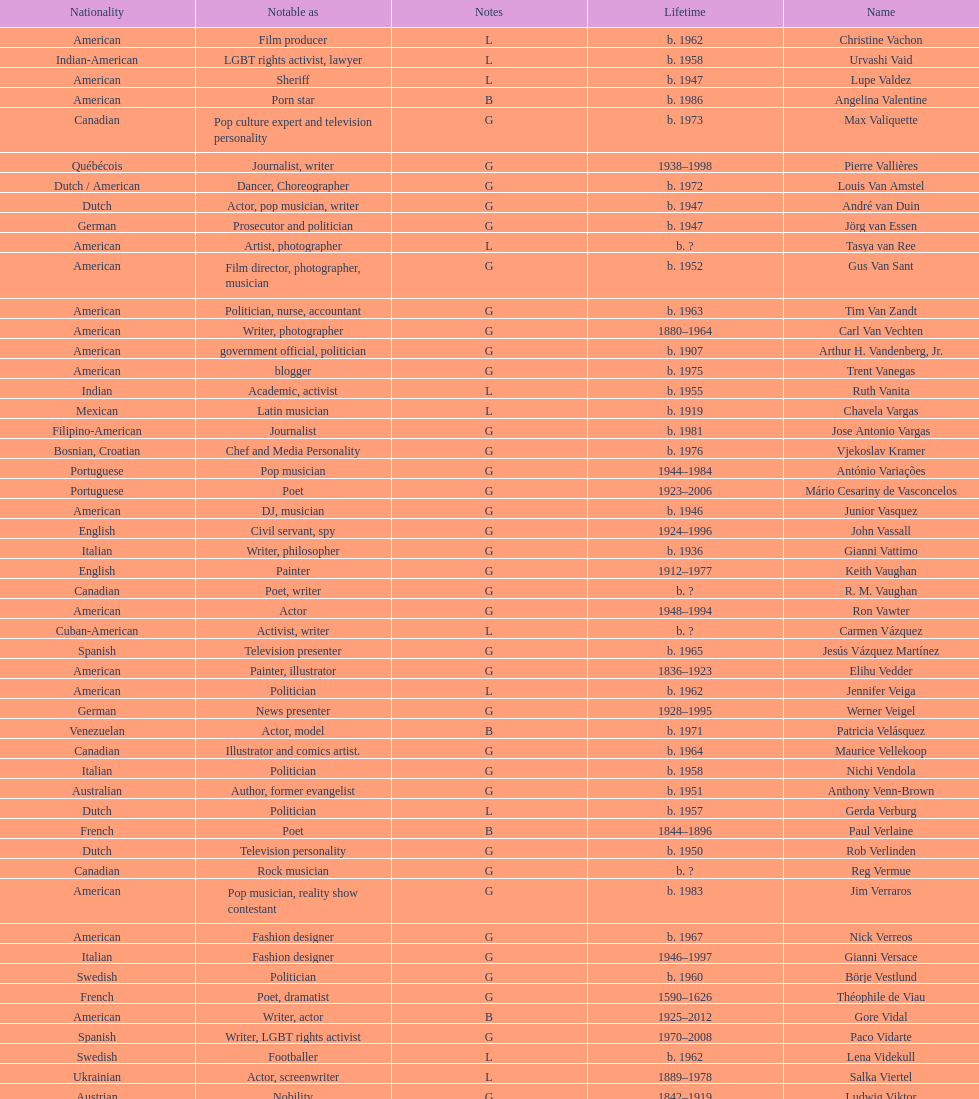Who was canadian, van amstel or valiquette? Valiquette. 